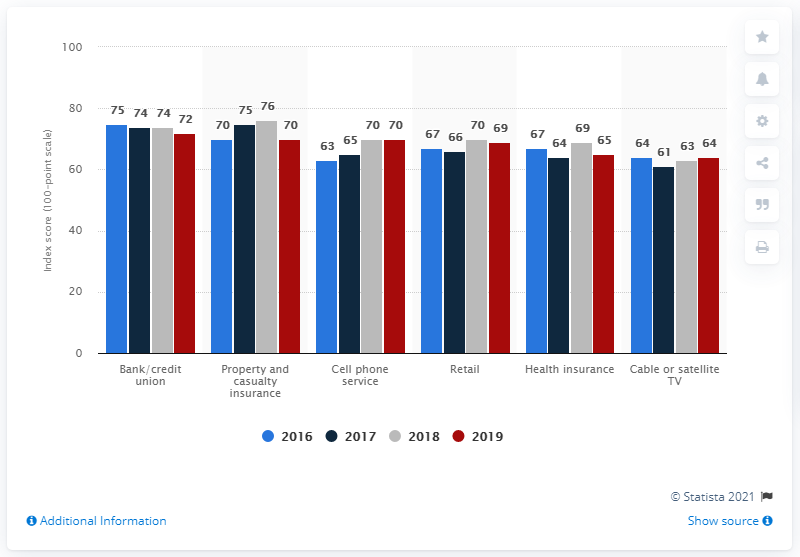Indicate a few pertinent items in this graphic. The average number of color bars displayed on cable or satellite TV is 63. In the 2019 data chart, the color that was shown was red. 